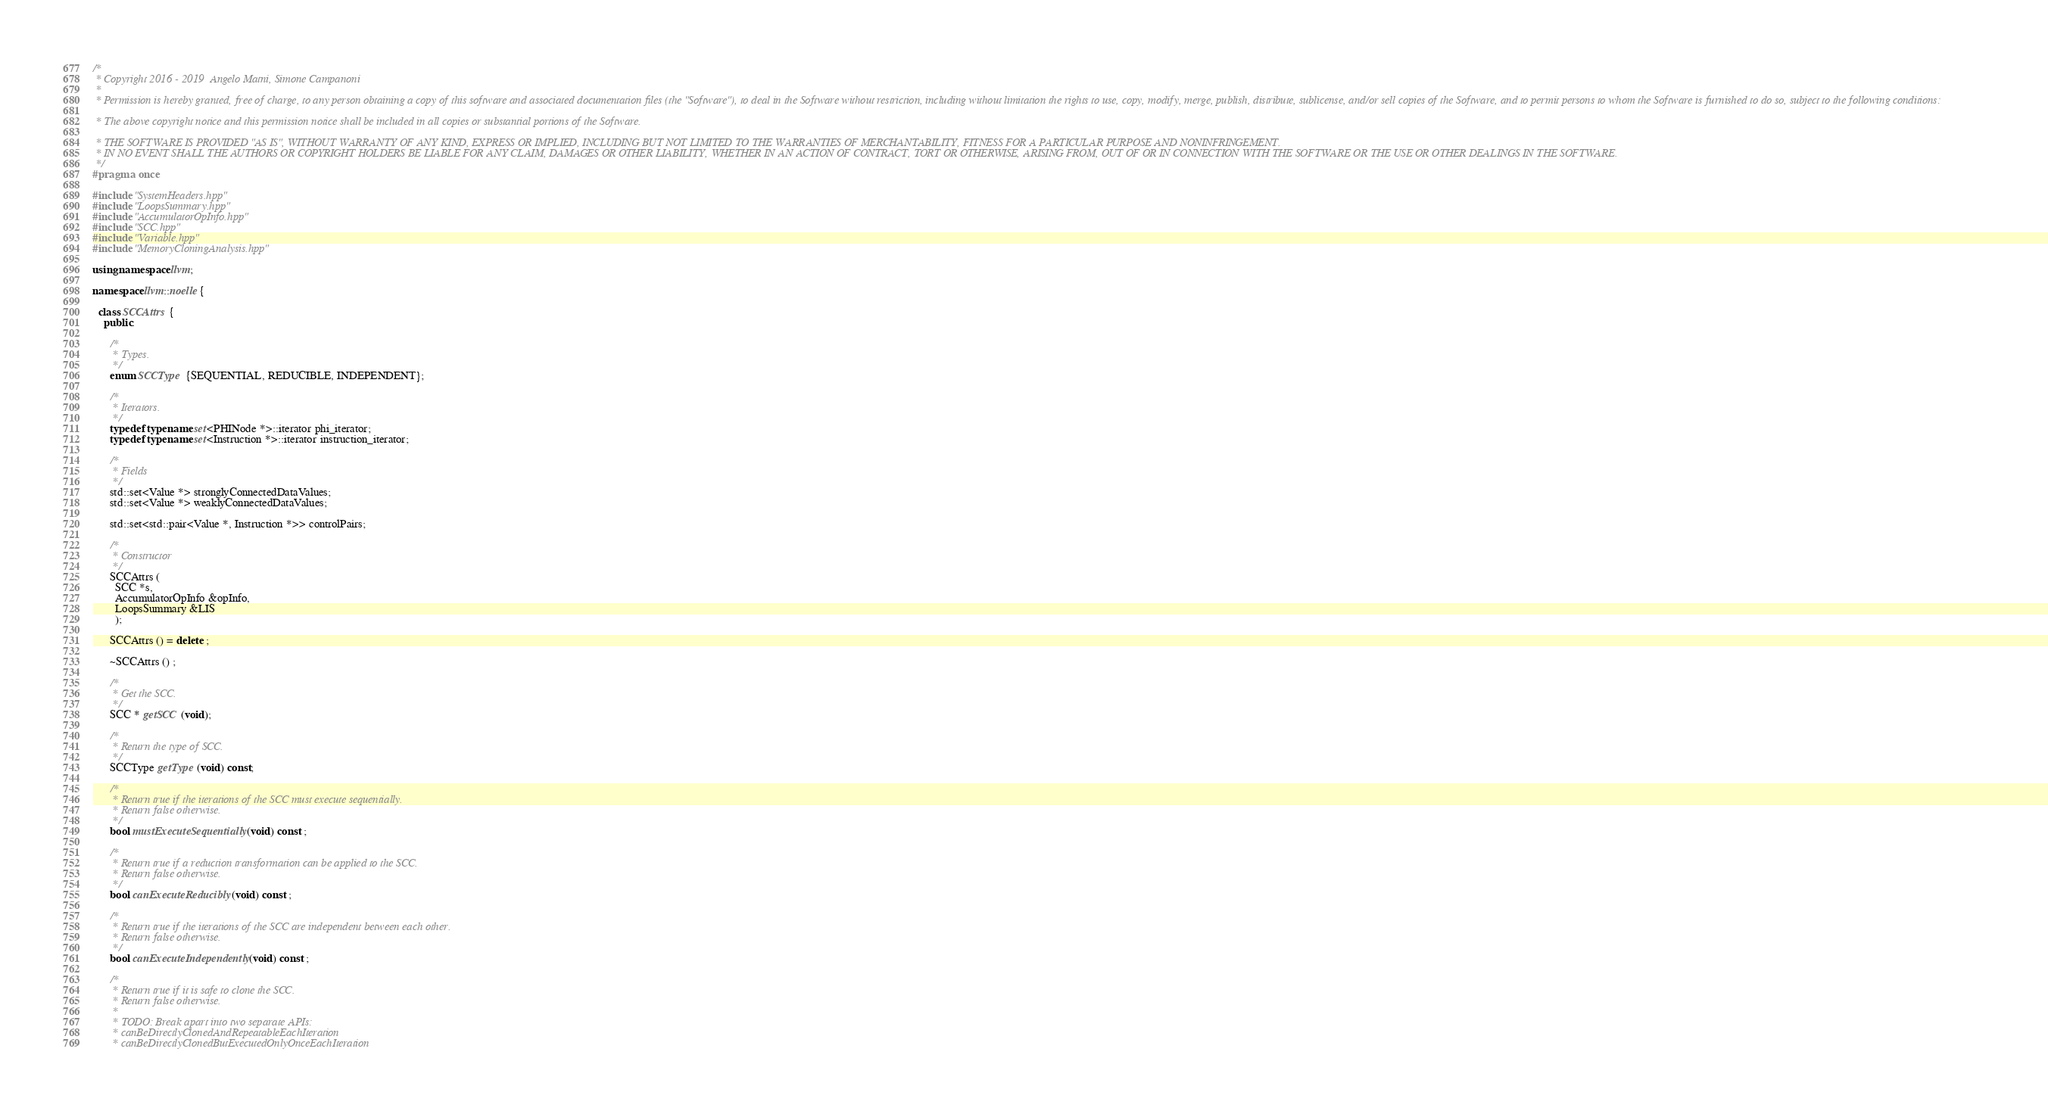Convert code to text. <code><loc_0><loc_0><loc_500><loc_500><_C++_>/*
 * Copyright 2016 - 2019  Angelo Matni, Simone Campanoni
 *
 * Permission is hereby granted, free of charge, to any person obtaining a copy of this software and associated documentation files (the "Software"), to deal in the Software without restriction, including without limitation the rights to use, copy, modify, merge, publish, distribute, sublicense, and/or sell copies of the Software, and to permit persons to whom the Software is furnished to do so, subject to the following conditions:

 * The above copyright notice and this permission notice shall be included in all copies or substantial portions of the Software.

 * THE SOFTWARE IS PROVIDED "AS IS", WITHOUT WARRANTY OF ANY KIND, EXPRESS OR IMPLIED, INCLUDING BUT NOT LIMITED TO THE WARRANTIES OF MERCHANTABILITY, FITNESS FOR A PARTICULAR PURPOSE AND NONINFRINGEMENT. 
 * IN NO EVENT SHALL THE AUTHORS OR COPYRIGHT HOLDERS BE LIABLE FOR ANY CLAIM, DAMAGES OR OTHER LIABILITY, WHETHER IN AN ACTION OF CONTRACT, TORT OR OTHERWISE, ARISING FROM, OUT OF OR IN CONNECTION WITH THE SOFTWARE OR THE USE OR OTHER DEALINGS IN THE SOFTWARE.
 */
#pragma once

#include "SystemHeaders.hpp"
#include "LoopsSummary.hpp"
#include "AccumulatorOpInfo.hpp"
#include "SCC.hpp"
#include "Variable.hpp"
#include "MemoryCloningAnalysis.hpp"

using namespace llvm;

namespace llvm::noelle {

  class SCCAttrs {
    public:

      /*
       * Types.
       */
      enum SCCType {SEQUENTIAL, REDUCIBLE, INDEPENDENT};

      /*
       * Iterators.
       */
      typedef typename set<PHINode *>::iterator phi_iterator;
      typedef typename set<Instruction *>::iterator instruction_iterator;

      /*
       * Fields
       */
      std::set<Value *> stronglyConnectedDataValues;
      std::set<Value *> weaklyConnectedDataValues;

      std::set<std::pair<Value *, Instruction *>> controlPairs;

      /*
       * Constructor
       */
      SCCAttrs (
        SCC *s, 
        AccumulatorOpInfo &opInfo,
        LoopsSummary &LIS
        );

      SCCAttrs () = delete ;

      ~SCCAttrs () ;

      /*
       * Get the SCC.
       */
      SCC * getSCC (void);

      /*
       * Return the type of SCC.
       */
      SCCType getType (void) const;

      /*
       * Return true if the iterations of the SCC must execute sequentially.
       * Return false otherwise.
       */
      bool mustExecuteSequentially (void) const ;

      /*
       * Return true if a reduction transformation can be applied to the SCC. 
       * Return false otherwise.
       */
      bool canExecuteReducibly (void) const ;

      /*
       * Return true if the iterations of the SCC are independent between each other.
       * Return false otherwise.
       */
      bool canExecuteIndependently (void) const ;

      /*
       * Return true if it is safe to clone the SCC.
       * Return false otherwise.
       * 
       * TODO: Break apart into two separate APIs:
       * canBeDirectlyClonedAndRepeatableEachIteration
       * canBeDirectlyClonedButExecutedOnlyOnceEachIteration</code> 